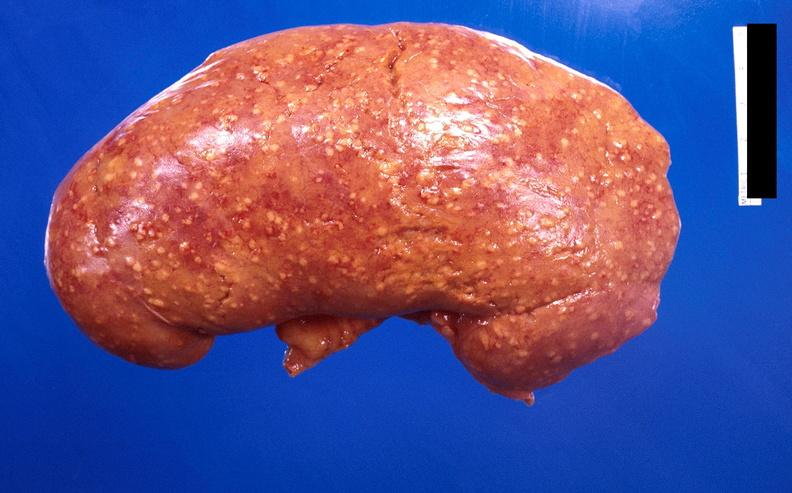what does this image show?
Answer the question using a single word or phrase. Kidney 